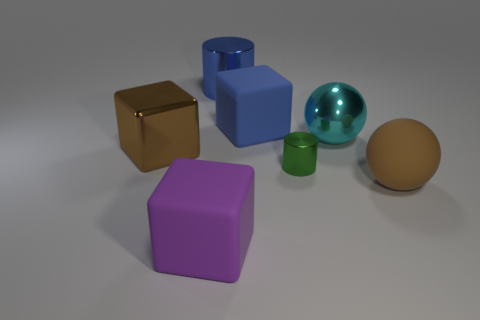What is the color of the large metal object that is both in front of the blue shiny thing and right of the large purple block?
Make the answer very short. Cyan. What number of objects are cubes that are in front of the small green thing or small green shiny cylinders?
Your answer should be compact. 2. How many other objects are there of the same color as the metal sphere?
Provide a short and direct response. 0. Are there the same number of objects in front of the green shiny thing and shiny cylinders?
Make the answer very short. Yes. What number of big blue things are left of the ball that is on the left side of the brown thing on the right side of the metal ball?
Provide a short and direct response. 2. Is there anything else that has the same size as the green metal object?
Your answer should be compact. No. Is the size of the blue metallic object the same as the object that is left of the purple thing?
Offer a very short reply. Yes. How many large red objects are there?
Make the answer very short. 0. Do the cylinder that is behind the tiny cylinder and the brown object that is to the right of the blue cylinder have the same size?
Provide a succinct answer. Yes. The other large object that is the same shape as the cyan thing is what color?
Your answer should be very brief. Brown. 